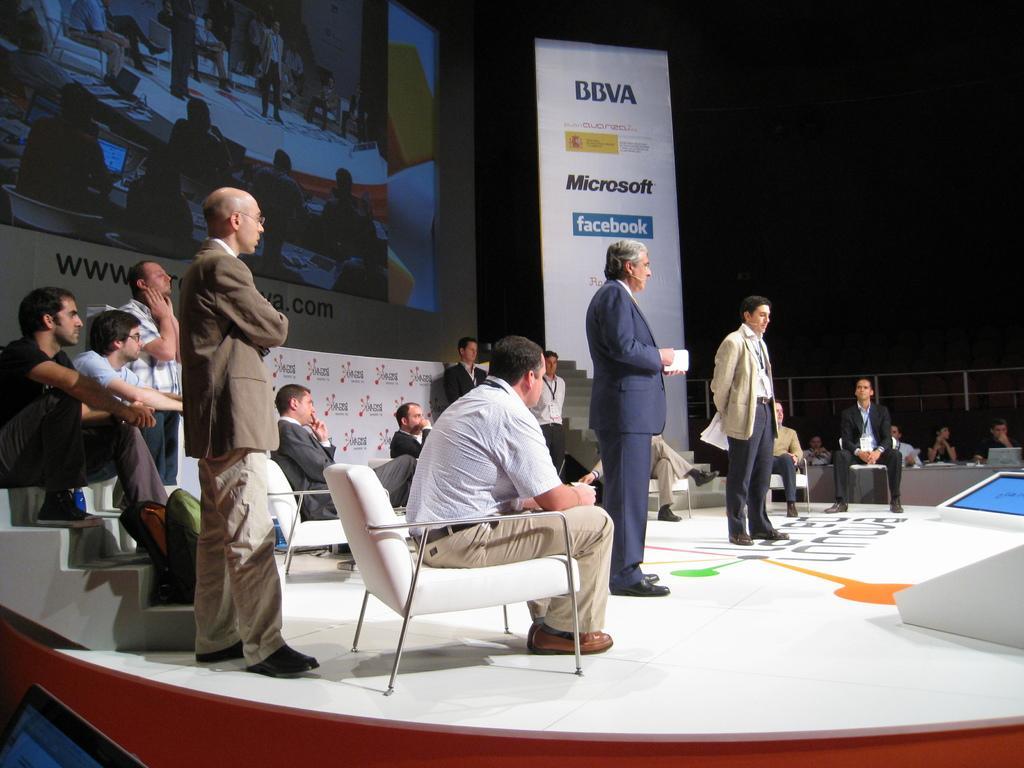How would you summarize this image in a sentence or two? In this image we can see some of the people standing and some people sitting, here some of the men are sitting on stairs and some of the men are sitting on chair, in the background we can see digital screen, on the right side it and see a banner it consists of Microsoft, Facebook and we can read B B V A on the banner. 